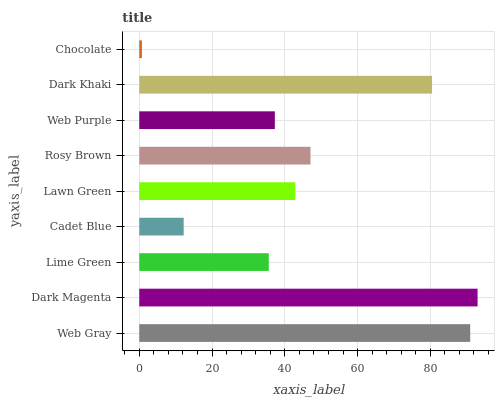Is Chocolate the minimum?
Answer yes or no. Yes. Is Dark Magenta the maximum?
Answer yes or no. Yes. Is Lime Green the minimum?
Answer yes or no. No. Is Lime Green the maximum?
Answer yes or no. No. Is Dark Magenta greater than Lime Green?
Answer yes or no. Yes. Is Lime Green less than Dark Magenta?
Answer yes or no. Yes. Is Lime Green greater than Dark Magenta?
Answer yes or no. No. Is Dark Magenta less than Lime Green?
Answer yes or no. No. Is Lawn Green the high median?
Answer yes or no. Yes. Is Lawn Green the low median?
Answer yes or no. Yes. Is Rosy Brown the high median?
Answer yes or no. No. Is Cadet Blue the low median?
Answer yes or no. No. 